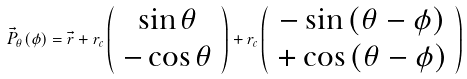<formula> <loc_0><loc_0><loc_500><loc_500>\vec { P } _ { \theta } ( \phi ) = \vec { r } + r _ { c } \left ( \begin{array} { c } \sin { \theta } \\ - \cos { \theta } \end{array} \right ) + r _ { c } \left ( \begin{array} { c } - \sin { ( \theta - \phi ) } \\ + \cos { ( \theta - \phi ) } \end{array} \right )</formula> 